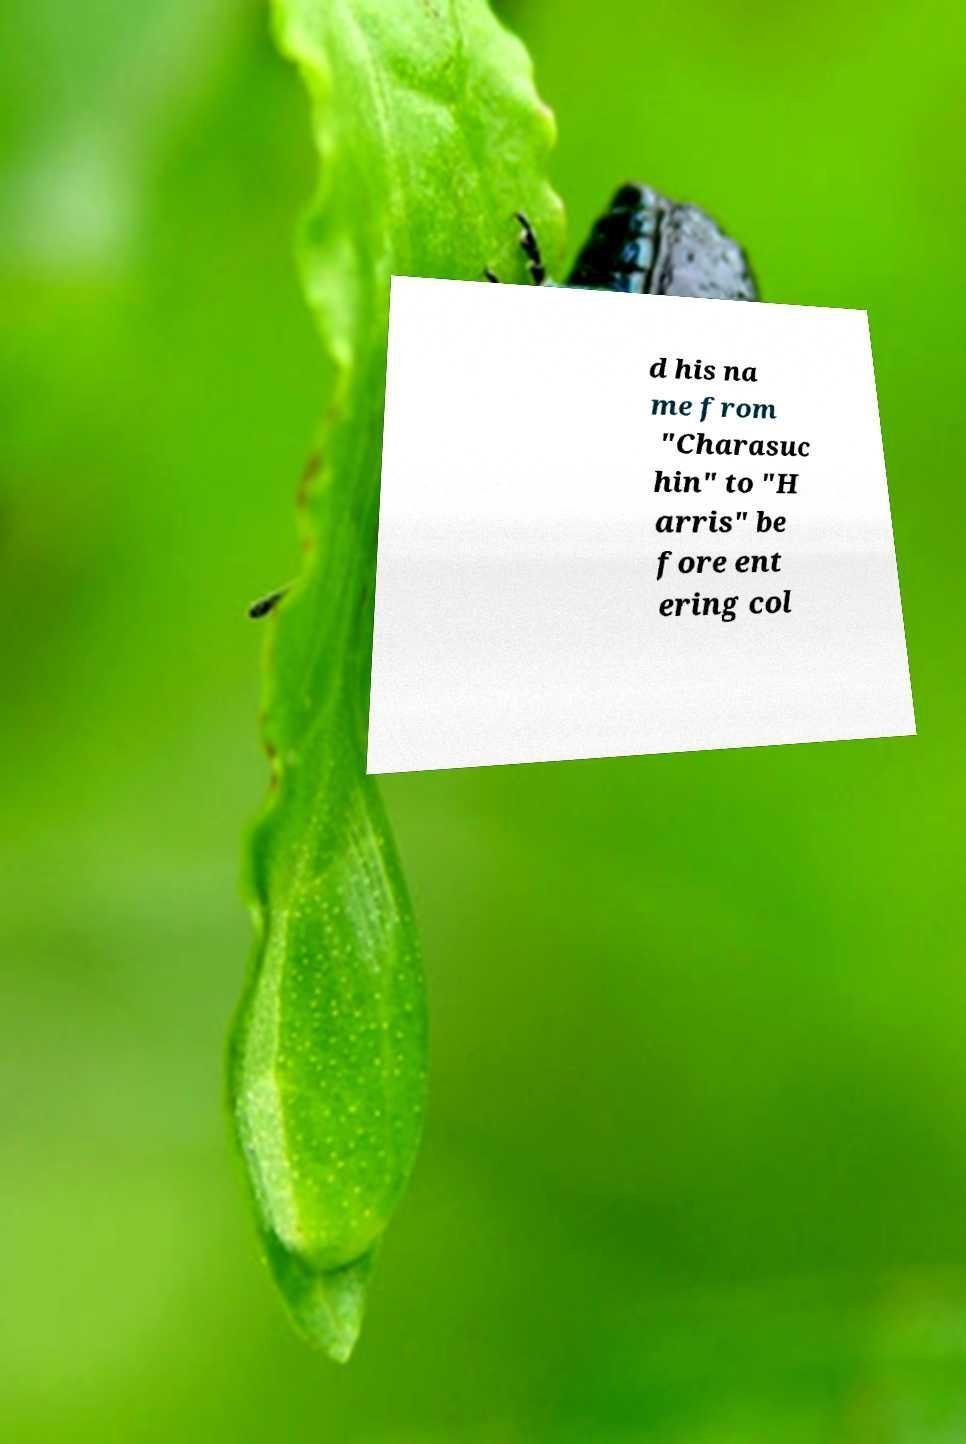I need the written content from this picture converted into text. Can you do that? d his na me from "Charasuc hin" to "H arris" be fore ent ering col 